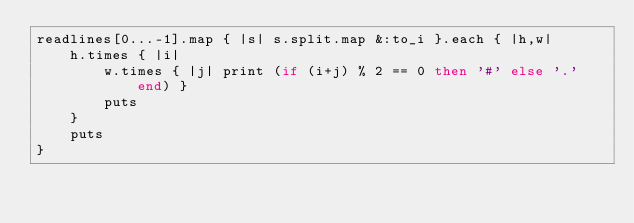Convert code to text. <code><loc_0><loc_0><loc_500><loc_500><_Ruby_>readlines[0...-1].map { |s| s.split.map &:to_i }.each { |h,w|
    h.times { |i|
        w.times { |j| print (if (i+j) % 2 == 0 then '#' else '.' end) }
        puts
    }
    puts
}</code> 